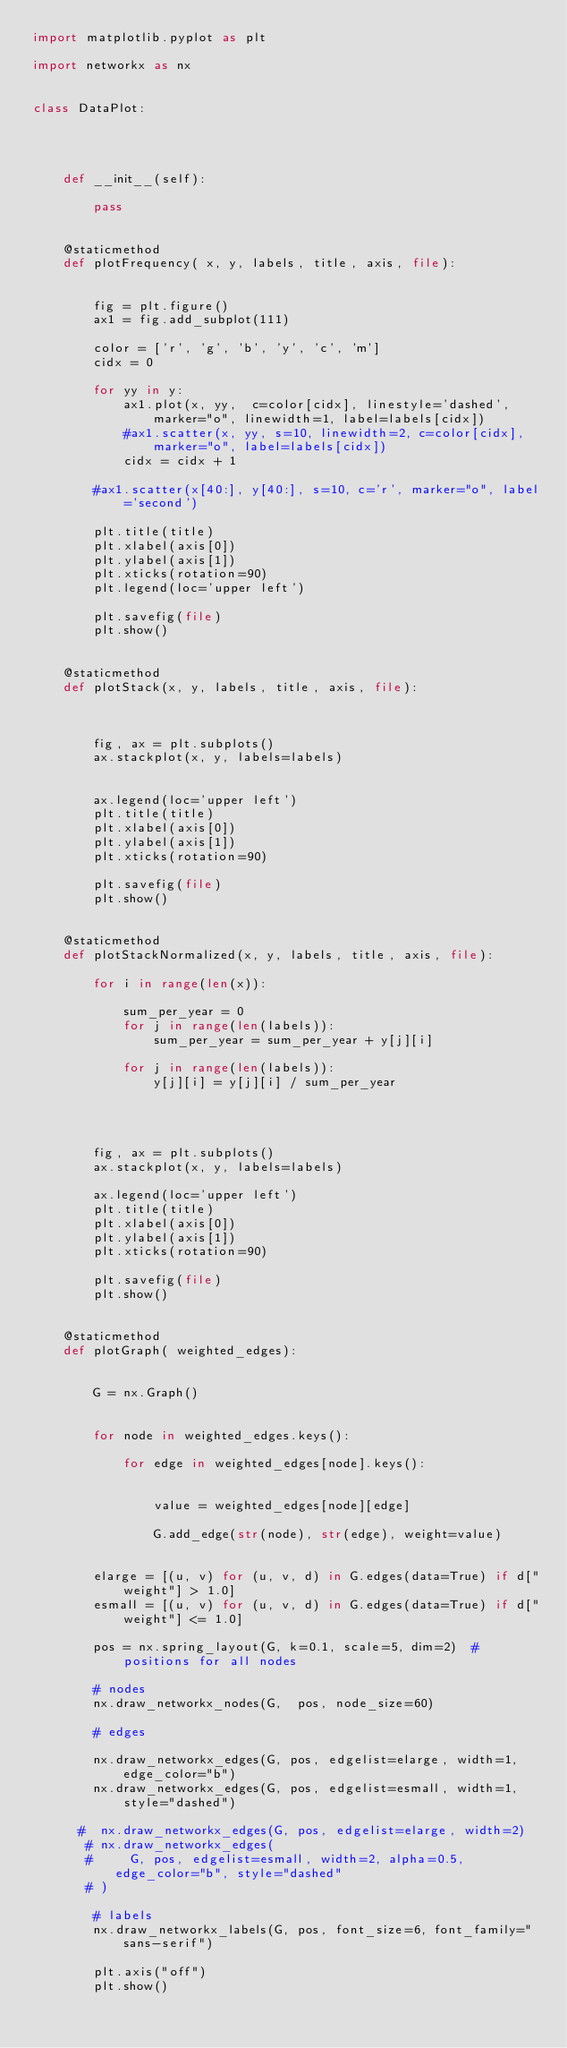<code> <loc_0><loc_0><loc_500><loc_500><_Python_>import matplotlib.pyplot as plt

import networkx as nx


class DataPlot:




    def __init__(self):

        pass


    @staticmethod
    def plotFrequency( x, y, labels, title, axis, file):


        fig = plt.figure()
        ax1 = fig.add_subplot(111)

        color = ['r', 'g', 'b', 'y', 'c', 'm']
        cidx = 0

        for yy in y:
            ax1.plot(x, yy,  c=color[cidx], linestyle='dashed', marker="o", linewidth=1, label=labels[cidx])
            #ax1.scatter(x, yy, s=10, linewidth=2, c=color[cidx], marker="o", label=labels[cidx])
            cidx = cidx + 1

        #ax1.scatter(x[40:], y[40:], s=10, c='r', marker="o", label='second')

        plt.title(title)
        plt.xlabel(axis[0])
        plt.ylabel(axis[1])
        plt.xticks(rotation=90)
        plt.legend(loc='upper left')

        plt.savefig(file)
        plt.show()


    @staticmethod
    def plotStack(x, y, labels, title, axis, file):



        fig, ax = plt.subplots()
        ax.stackplot(x, y, labels=labels)


        ax.legend(loc='upper left')
        plt.title(title)
        plt.xlabel(axis[0])
        plt.ylabel(axis[1])
        plt.xticks(rotation=90)

        plt.savefig(file)
        plt.show()


    @staticmethod
    def plotStackNormalized(x, y, labels, title, axis, file):

        for i in range(len(x)):

            sum_per_year = 0
            for j in range(len(labels)):
                sum_per_year = sum_per_year + y[j][i]

            for j in range(len(labels)):
                y[j][i] = y[j][i] / sum_per_year




        fig, ax = plt.subplots()
        ax.stackplot(x, y, labels=labels)

        ax.legend(loc='upper left')
        plt.title(title)
        plt.xlabel(axis[0])
        plt.ylabel(axis[1])
        plt.xticks(rotation=90)

        plt.savefig(file)
        plt.show()


    @staticmethod
    def plotGraph( weighted_edges):


        G = nx.Graph()


        for node in weighted_edges.keys():

            for edge in weighted_edges[node].keys():


                value = weighted_edges[node][edge]

                G.add_edge(str(node), str(edge), weight=value)


        elarge = [(u, v) for (u, v, d) in G.edges(data=True) if d["weight"] > 1.0]
        esmall = [(u, v) for (u, v, d) in G.edges(data=True) if d["weight"] <= 1.0]

        pos = nx.spring_layout(G, k=0.1, scale=5, dim=2)  # positions for all nodes

        # nodes
        nx.draw_networkx_nodes(G,  pos, node_size=60)

        # edges

        nx.draw_networkx_edges(G, pos, edgelist=elarge, width=1, edge_color="b")
        nx.draw_networkx_edges(G, pos, edgelist=esmall, width=1, style="dashed")

      #  nx.draw_networkx_edges(G, pos, edgelist=elarge, width=2)
       # nx.draw_networkx_edges(
       #     G, pos, edgelist=esmall, width=2, alpha=0.5, edge_color="b", style="dashed"
       # )

        # labels
        nx.draw_networkx_labels(G, pos, font_size=6, font_family="sans-serif")

        plt.axis("off")
        plt.show()</code> 